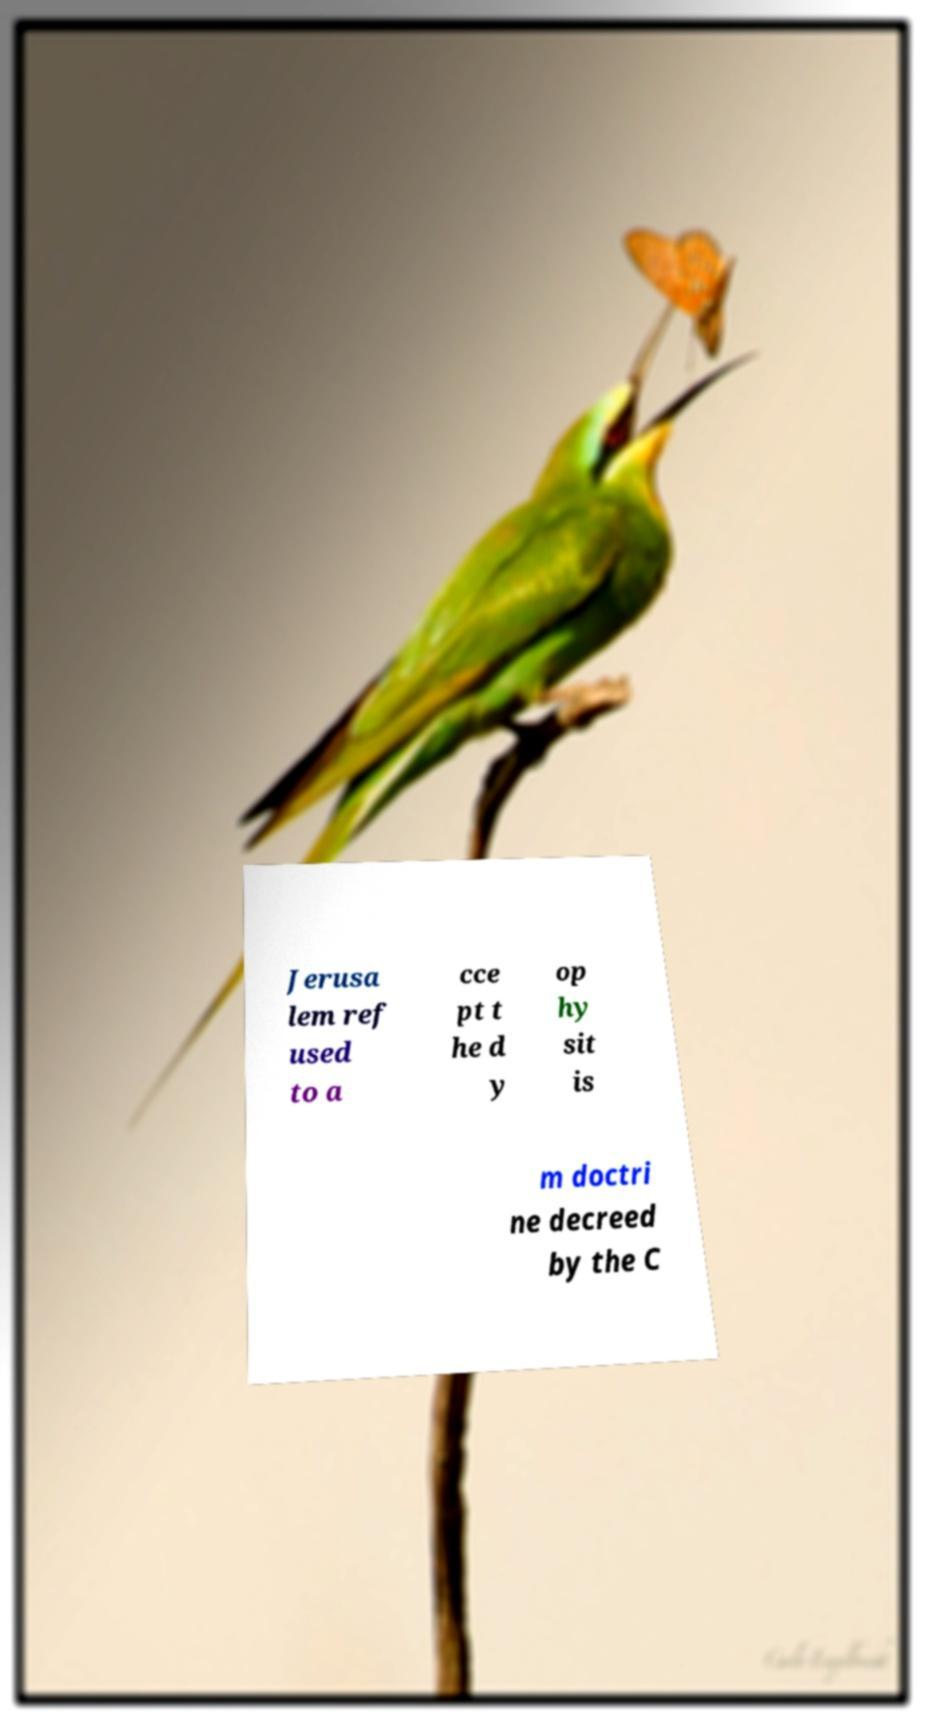What messages or text are displayed in this image? I need them in a readable, typed format. Jerusa lem ref used to a cce pt t he d y op hy sit is m doctri ne decreed by the C 